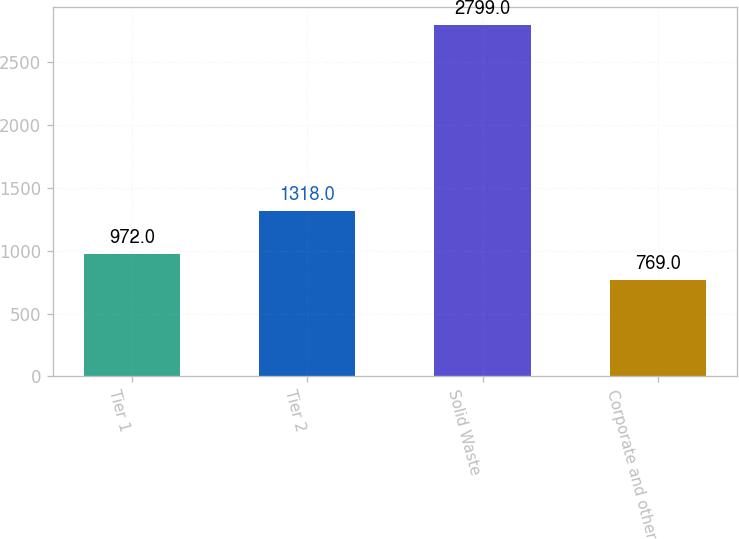Convert chart. <chart><loc_0><loc_0><loc_500><loc_500><bar_chart><fcel>Tier 1<fcel>Tier 2<fcel>Solid Waste<fcel>Corporate and other<nl><fcel>972<fcel>1318<fcel>2799<fcel>769<nl></chart> 